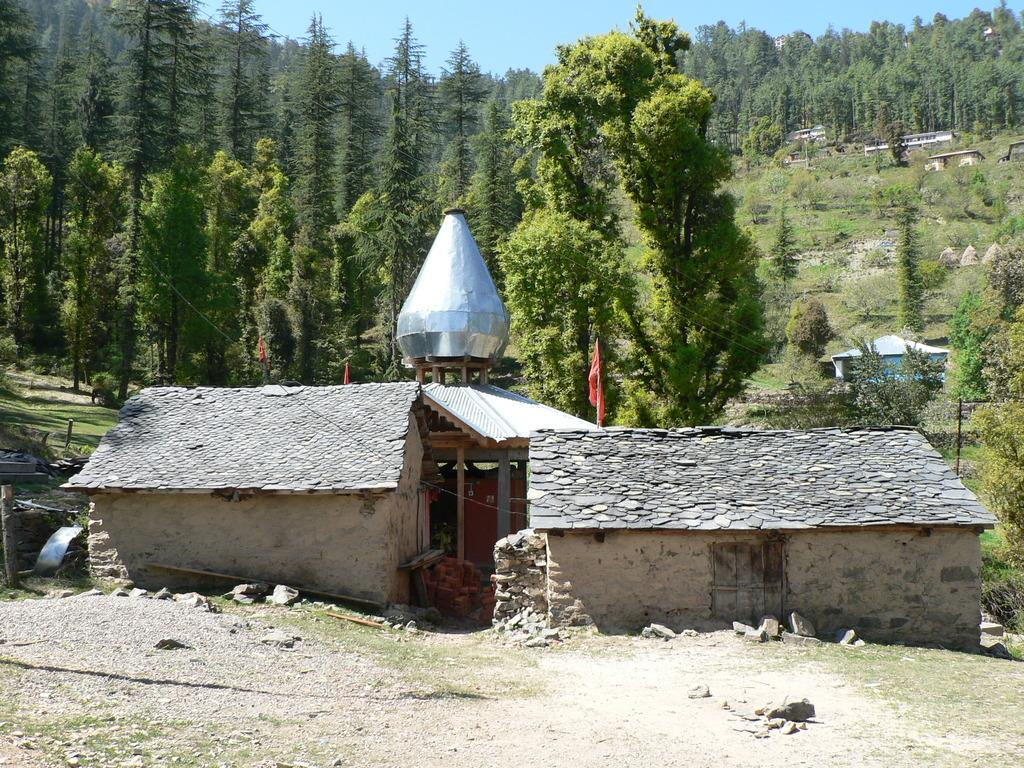What type of vegetation is present in the middle of the image? There are trees in the middle of the image. What is visible at the top of the image? The sky is visible at the top of the image. What type of structure can be seen in the middle of the image? There appears to be a house or similar structure in the middle of the image. What type of watch can be seen hanging from the wire in the image? There is no watch or wire present in the image. Can you describe the bee's behavior in the image? There are no bees present in the image. 